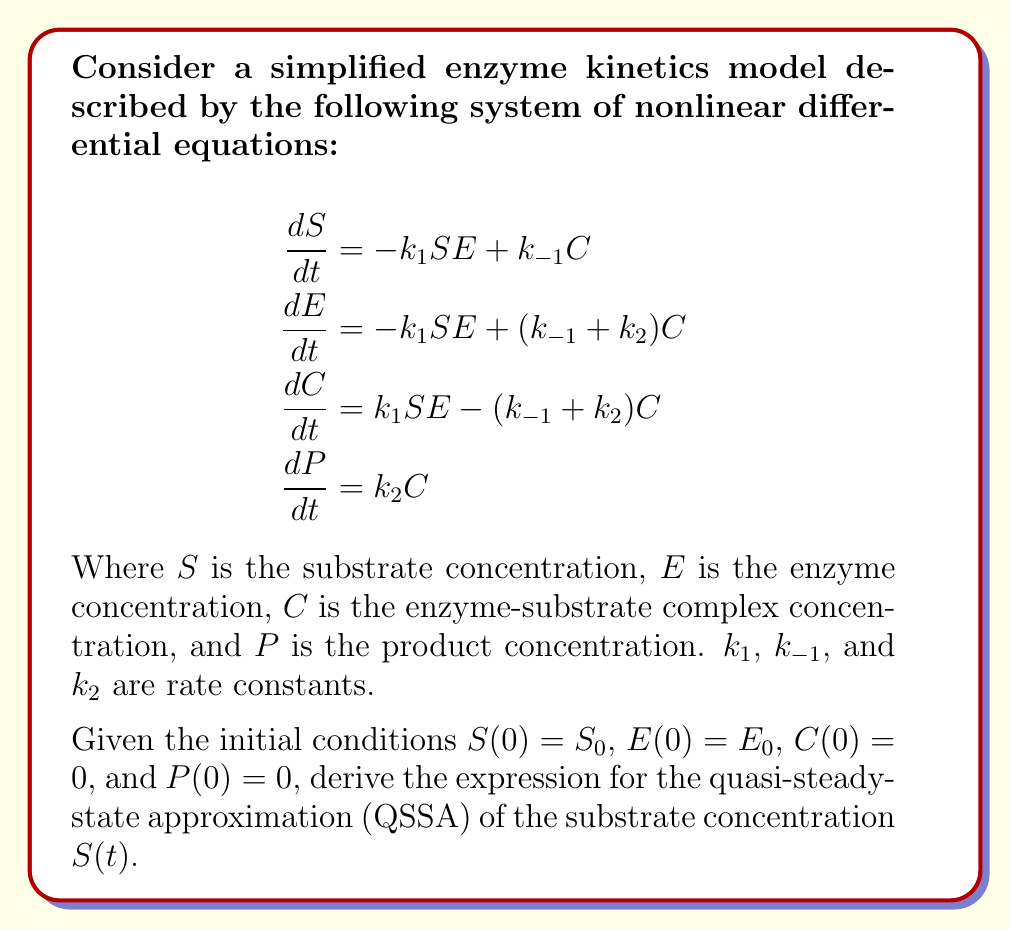Can you solve this math problem? To solve this problem, we'll follow these steps:

1) First, we apply the quasi-steady-state approximation, which assumes that the concentration of the enzyme-substrate complex $C$ reaches a steady state quickly. This means:

   $$\frac{dC}{dt} \approx 0$$

2) From the third equation in the system:

   $$k_1SE - (k_{-1} + k_2)C = 0$$

3) Solve this for $C$:

   $$C = \frac{k_1SE}{k_{-1} + k_2}$$

4) Define the Michaelis-Menten constant $K_m$:

   $$K_m = \frac{k_{-1} + k_2}{k_1}$$

5) Rewrite the expression for $C$:

   $$C = \frac{SE}{K_m}$$

6) Now, we use the conservation of enzyme:

   $$E_0 = E + C$$

   Where $E_0$ is the total enzyme concentration.

7) Substitute the expression for $C$:

   $$E_0 = E + \frac{SE}{K_m}$$

8) Solve for $E$:

   $$E = E_0 - \frac{SE}{K_m}$$

9) Now, substitute this into the equation for $\frac{dS}{dt}$:

   $$\frac{dS}{dt} = -k_1S(E_0 - \frac{SE}{K_m}) + k_{-1}\frac{SE}{K_m}$$

10) Simplify:

    $$\frac{dS}{dt} = -k_1E_0S + \frac{k_1E_0S^2}{K_m + S}$$

11) Define the maximum reaction velocity $V_{max} = k_2E_0$:

    $$\frac{dS}{dt} = -\frac{V_{max}S}{K_m + S}$$

12) This is the final form of the QSSA for the substrate concentration. The solution to this differential equation gives the time-dependent substrate concentration $S(t)$.
Answer: $$\frac{dS}{dt} = -\frac{V_{max}S}{K_m + S}$$ 